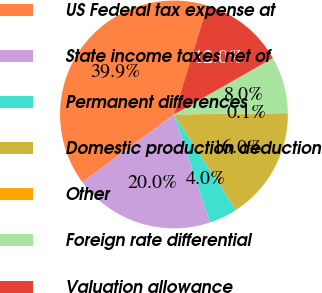Convert chart. <chart><loc_0><loc_0><loc_500><loc_500><pie_chart><fcel>US Federal tax expense at<fcel>State income taxes net of<fcel>Permanent differences<fcel>Domestic production deduction<fcel>Other<fcel>Foreign rate differential<fcel>Valuation allowance<nl><fcel>39.9%<fcel>19.98%<fcel>4.04%<fcel>15.99%<fcel>0.05%<fcel>8.02%<fcel>12.01%<nl></chart> 